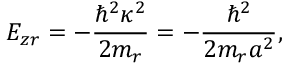<formula> <loc_0><loc_0><loc_500><loc_500>E _ { z r } = - \frac { \hbar { ^ } { 2 } \kappa ^ { 2 } } { 2 m _ { r } } = - \frac { \hbar { ^ } { 2 } } { 2 m _ { r } a ^ { 2 } } ,</formula> 